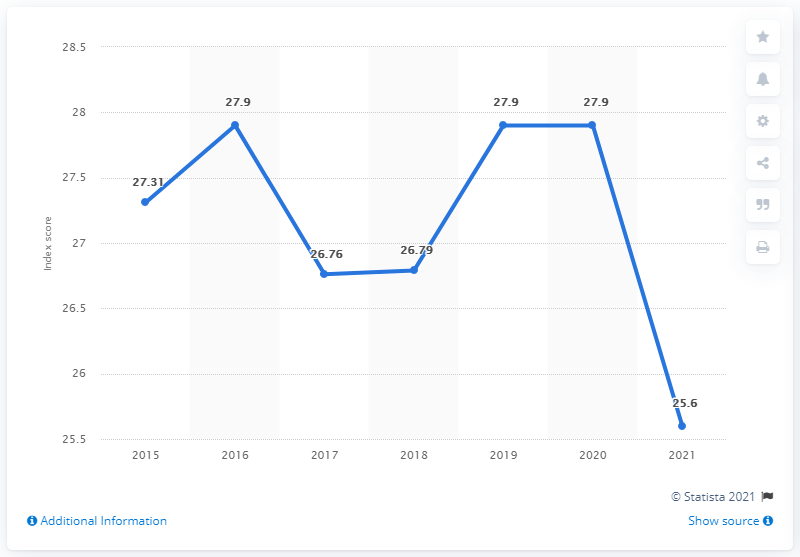What was the Dominican Republic's press freedom index a year earlier?
 27.9 